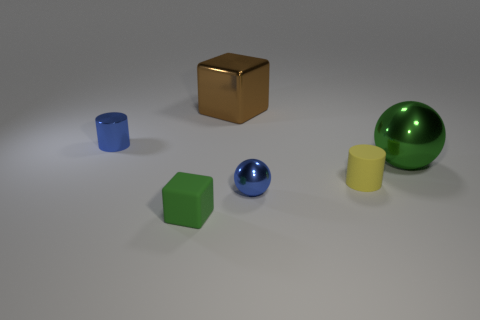Subtract 0 cyan balls. How many objects are left? 6 Subtract all cylinders. How many objects are left? 4 Subtract 2 spheres. How many spheres are left? 0 Subtract all gray spheres. Subtract all brown cylinders. How many spheres are left? 2 Subtract all red cylinders. How many purple spheres are left? 0 Subtract all small brown rubber cylinders. Subtract all brown blocks. How many objects are left? 5 Add 6 large brown metal cubes. How many large brown metal cubes are left? 7 Add 6 blue cylinders. How many blue cylinders exist? 7 Add 2 yellow metallic cubes. How many objects exist? 8 Subtract all green cubes. How many cubes are left? 1 